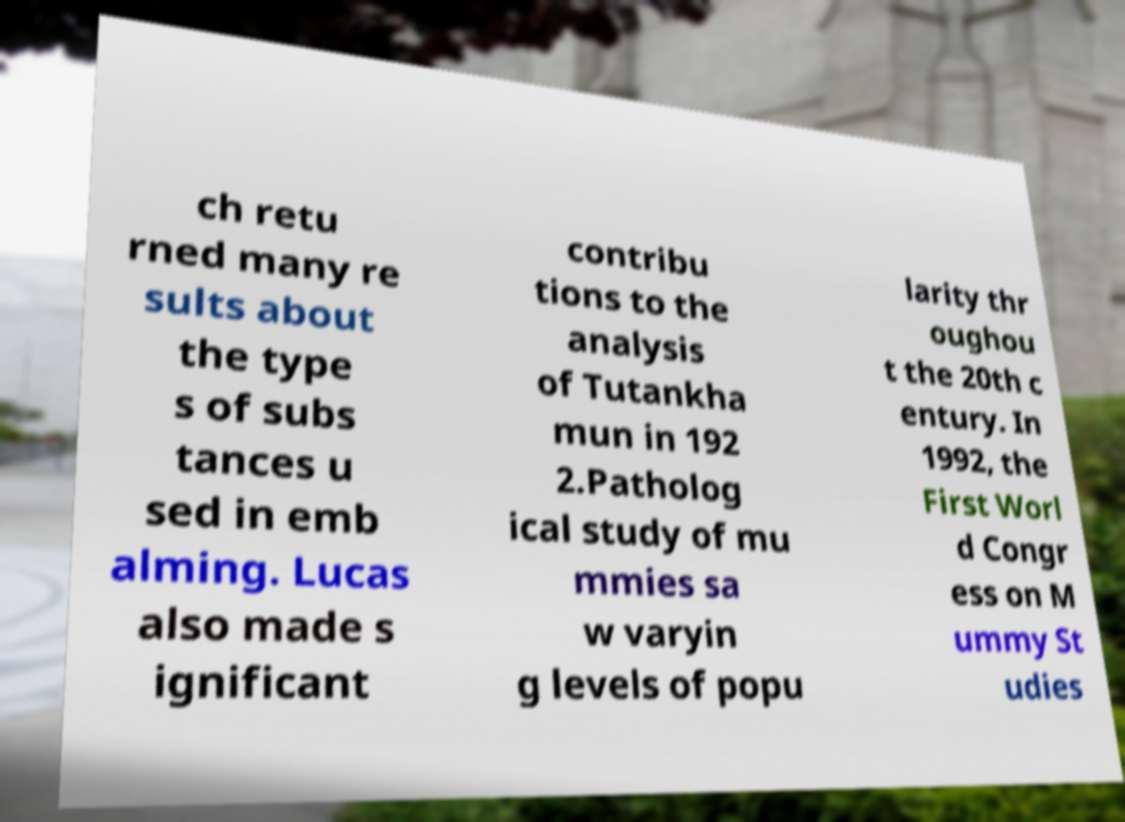I need the written content from this picture converted into text. Can you do that? ch retu rned many re sults about the type s of subs tances u sed in emb alming. Lucas also made s ignificant contribu tions to the analysis of Tutankha mun in 192 2.Patholog ical study of mu mmies sa w varyin g levels of popu larity thr oughou t the 20th c entury. In 1992, the First Worl d Congr ess on M ummy St udies 